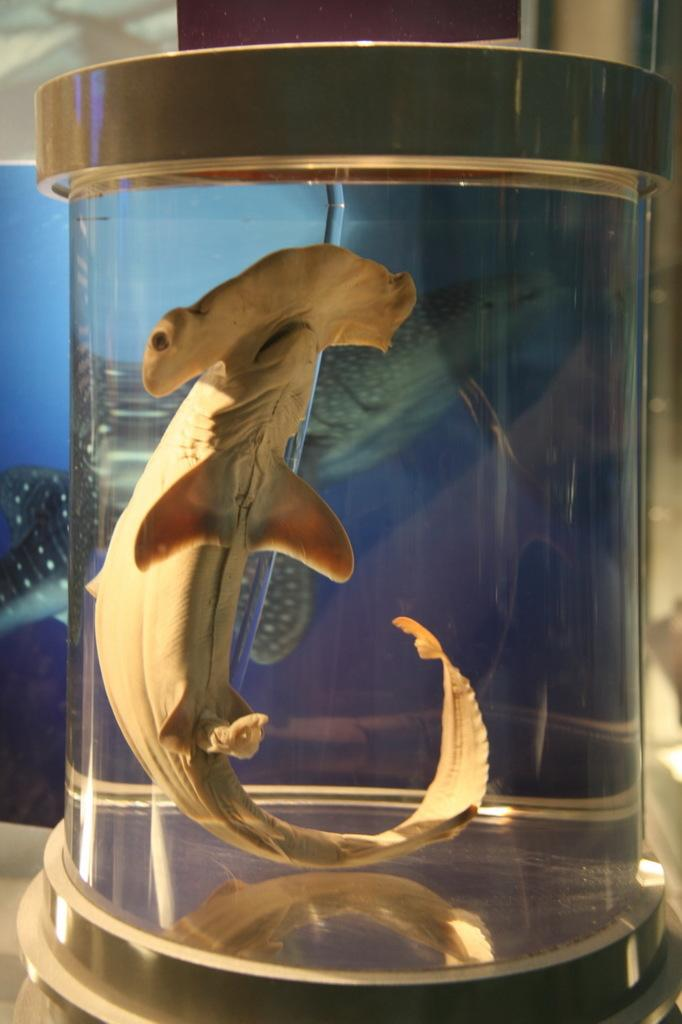What type of animal is in the image? There is a fish in the image. Where is the fish located? The fish is inside a water bottle. What type of base is supporting the fish in the image? There is no base present in the image; the fish is inside a water bottle. How many pies are visible in the image? There are no pies present in the image; it features a fish inside a water bottle. 